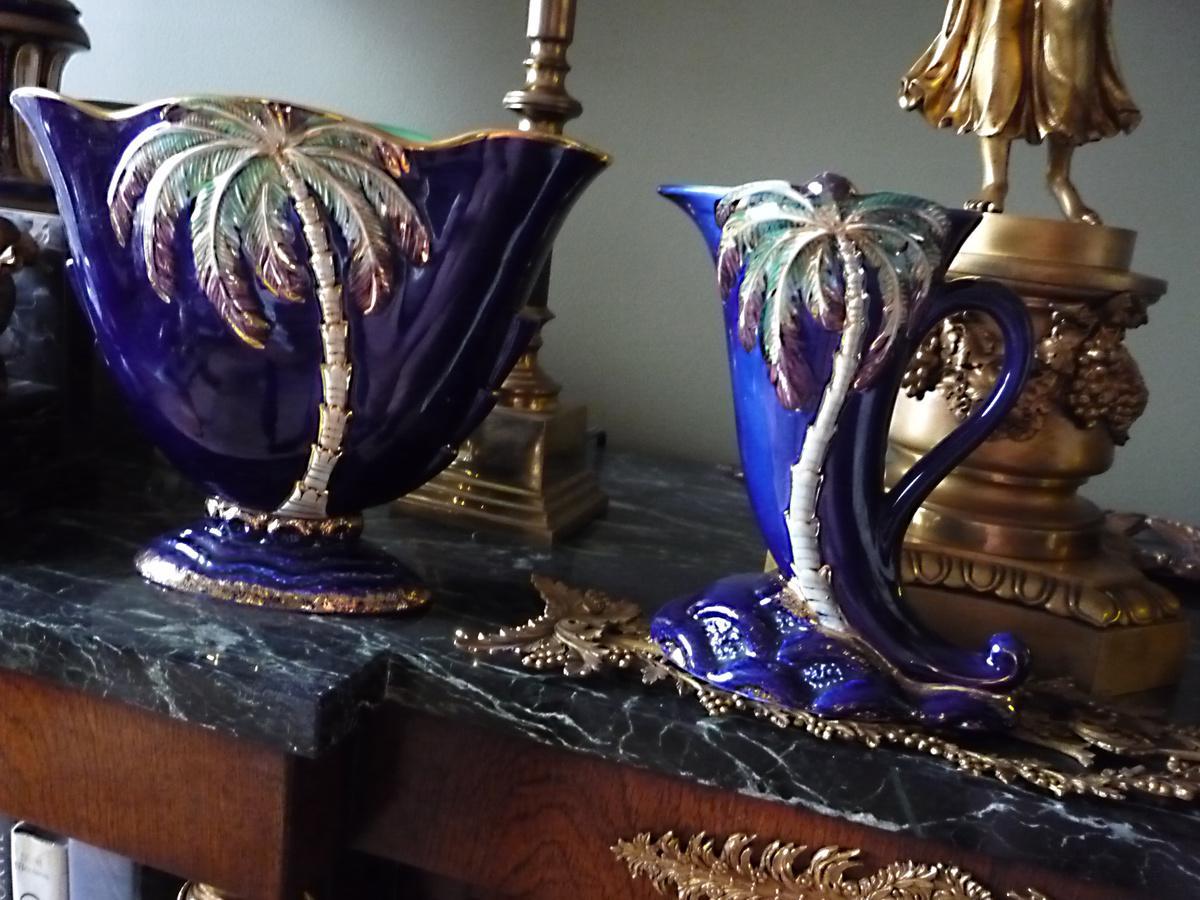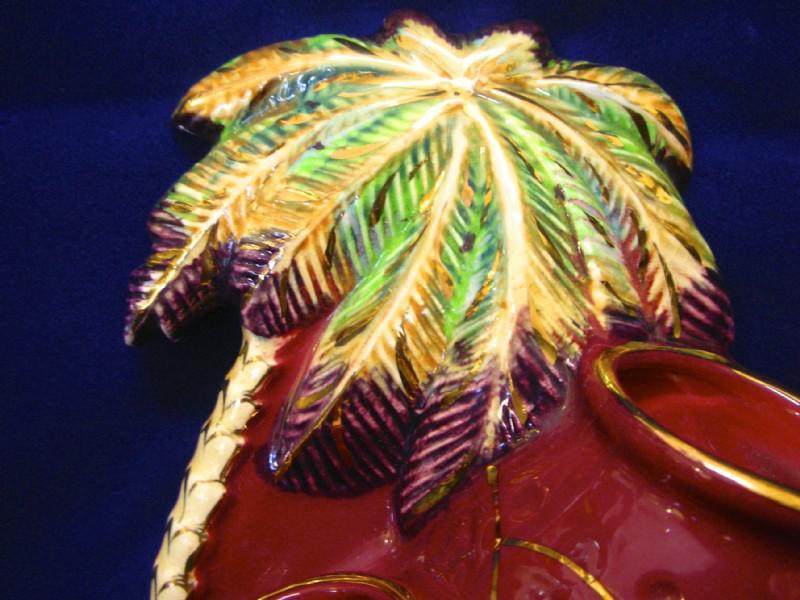The first image is the image on the left, the second image is the image on the right. Considering the images on both sides, is "the right image contains a pitcher with a handle" valid? Answer yes or no. No. The first image is the image on the left, the second image is the image on the right. For the images displayed, is the sentence "There is at least 1 blue decorative vase with a palm tree on it." factually correct? Answer yes or no. Yes. 